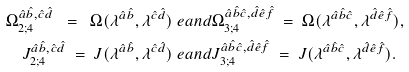Convert formula to latex. <formula><loc_0><loc_0><loc_500><loc_500>\Omega ^ { \hat { a } \hat { b } , \hat { c } \hat { d } } _ { 2 ; 4 } \ = \ \Omega ( \lambda ^ { \hat { a } \hat { b } } , \lambda ^ { \hat { c } \hat { d } } ) & \ e a n d \Omega ^ { \hat { a } \hat { b } \hat { c } , \hat { d } \hat { e } \hat { f } } _ { 3 ; 4 } \ = \ \Omega ( \lambda ^ { \hat { a } \hat { b } \hat { c } } , \lambda ^ { \hat { d } \hat { e } \hat { f } } ) , \\ J ^ { \hat { a } \hat { b } , \hat { c } \hat { d } } _ { 2 ; 4 } \ = \ J ( \lambda ^ { \hat { a } \hat { b } } , \lambda ^ { \hat { c } \hat { d } } ) & \ e a n d J ^ { \hat { a } \hat { b } \hat { c } , \hat { d } \hat { e } \hat { f } } _ { 3 ; 4 } \ = \ J ( \lambda ^ { \hat { a } \hat { b } \hat { c } } , \lambda ^ { \hat { d } \hat { e } \hat { f } } ) .</formula> 